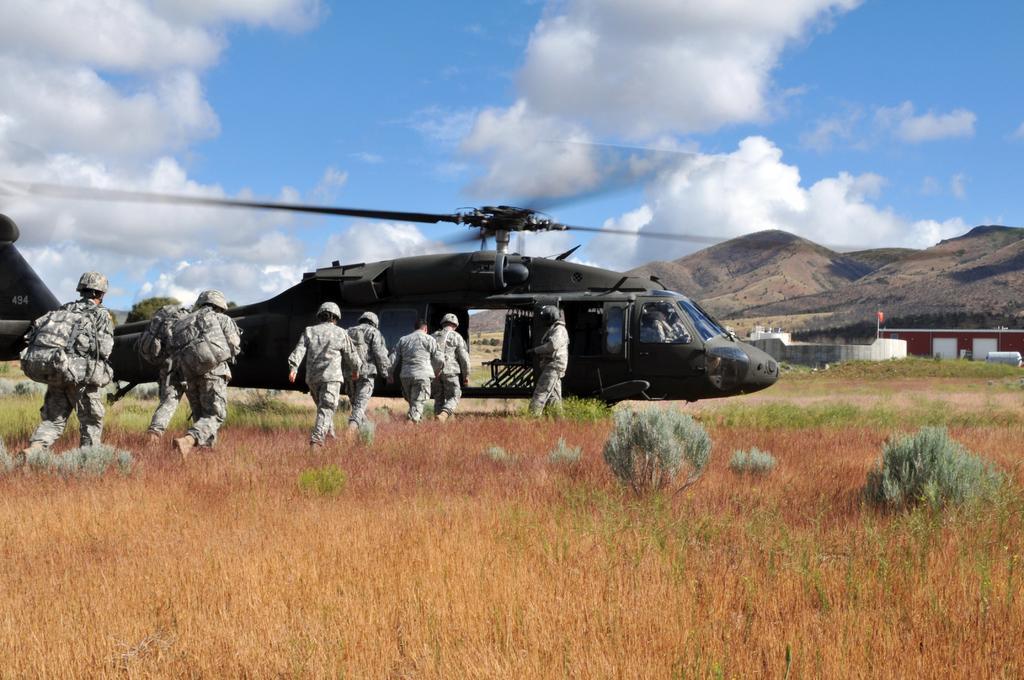Describe this image in one or two sentences. In this image I can see the grass which is brown and pink in color and few plants which are green in color. I an see few persons wearing uniform, bags and helmets are standing. I can see a black colored helicopter on the ground. In the background I can see few trees, a red colored flag, a mountain, a building and the sky. 